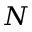<formula> <loc_0><loc_0><loc_500><loc_500>N</formula> 